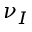<formula> <loc_0><loc_0><loc_500><loc_500>\nu _ { I }</formula> 